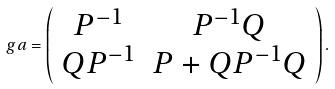Convert formula to latex. <formula><loc_0><loc_0><loc_500><loc_500>\ g a = \left ( \begin{array} { c c } P ^ { - 1 } & P ^ { - 1 } Q \\ Q P ^ { - 1 } & P + Q P ^ { - 1 } Q \end{array} \right ) .</formula> 